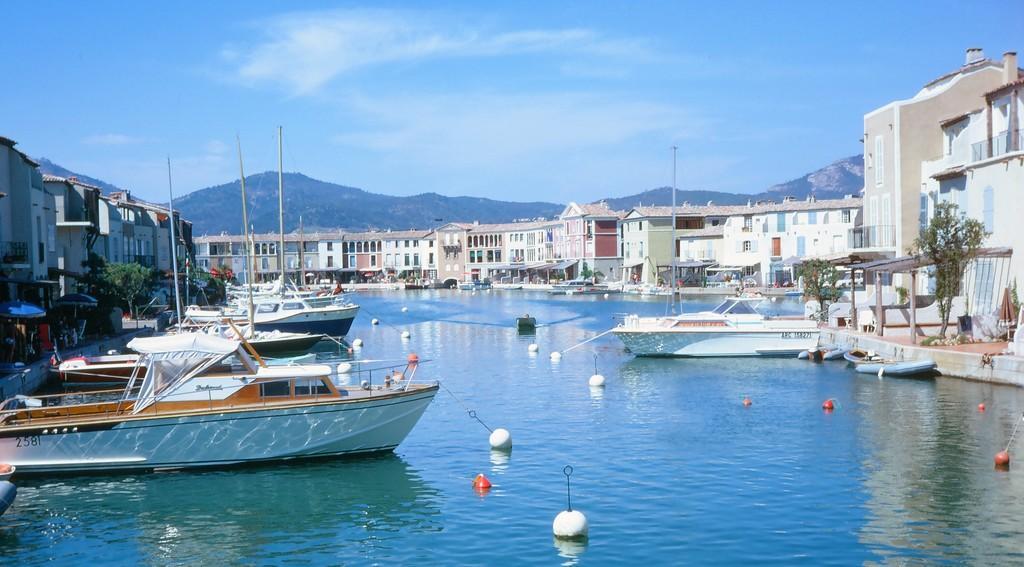Could you give a brief overview of what you see in this image? In the image in the center, we can see few boats and poles. In the background, we can see the sky, clouds, trees, buildings, poles, water etc. 